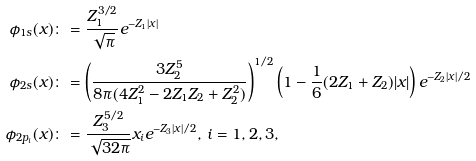<formula> <loc_0><loc_0><loc_500><loc_500>\phi _ { 1 s } ( x ) & \colon = \frac { Z _ { 1 } ^ { 3 / 2 } } { \sqrt { \pi } } e ^ { - Z _ { 1 } | x | } \\ \phi _ { 2 s } ( x ) & \colon = \left ( \frac { 3 Z _ { 2 } ^ { 5 } } { 8 \pi ( 4 Z _ { 1 } ^ { 2 } - 2 Z _ { 1 } Z _ { 2 } + Z _ { 2 } ^ { 2 } ) } \right ) ^ { 1 / 2 } \left ( 1 - \frac { 1 } { 6 } ( 2 Z _ { 1 } + Z _ { 2 } ) | x | \right ) e ^ { - Z _ { 2 } | x | / 2 } \\ \phi _ { 2 p _ { i } } ( x ) & \colon = \frac { Z _ { 3 } ^ { 5 / 2 } } { \sqrt { 3 2 \pi } } x _ { i } e ^ { - Z _ { 3 } | x | / 2 } , \, i = 1 , 2 , 3 ,</formula> 